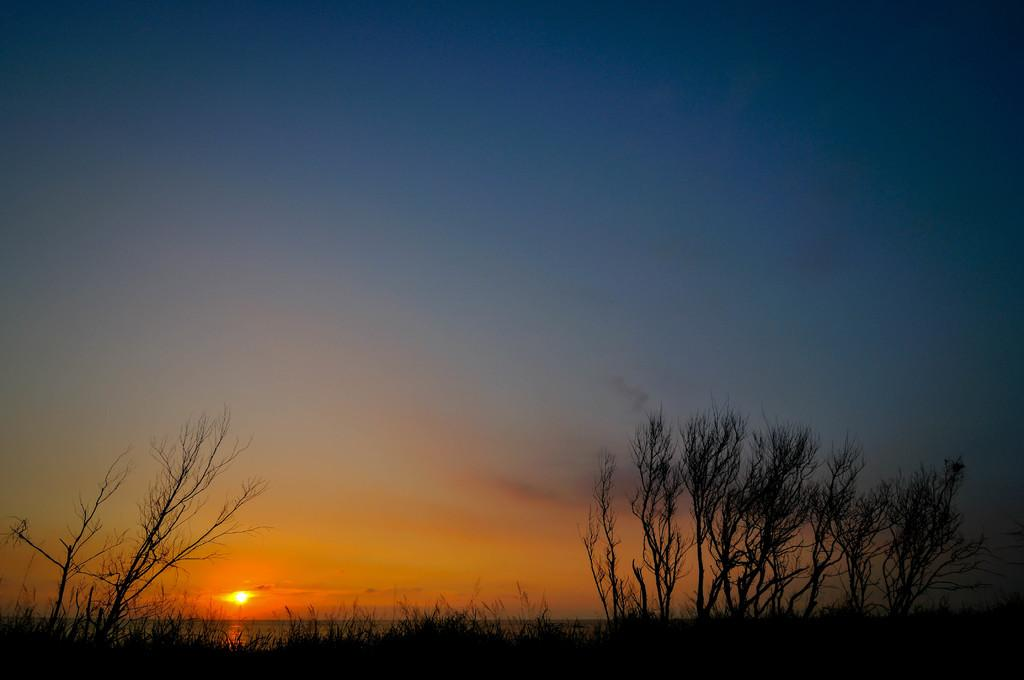What is happening to the sun in the image? The sun is rising in the sky in the image. What type of vegetation can be seen at the bottom of the image? There are plants at the bottom of the image. Can you describe the vegetation in the bottom left of the image? There are trees in the bottom left of the image. How about the vegetation in the bottom right of the image? There are trees in the bottom right of the image. What type of treatment is being administered to the geese in the image? There are no geese present in the image, so no treatment can be administered to them. 